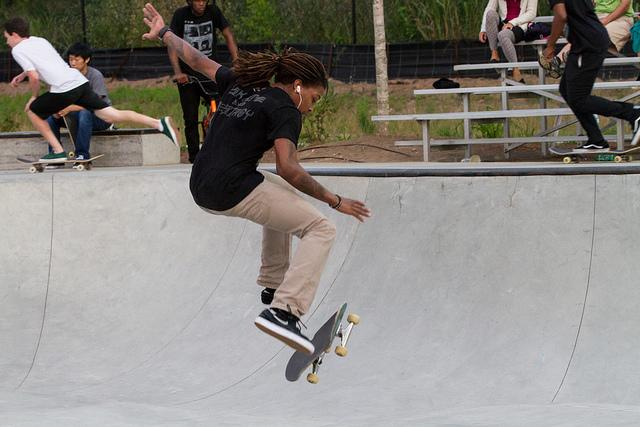What's the name of this type of skating area? skate park 